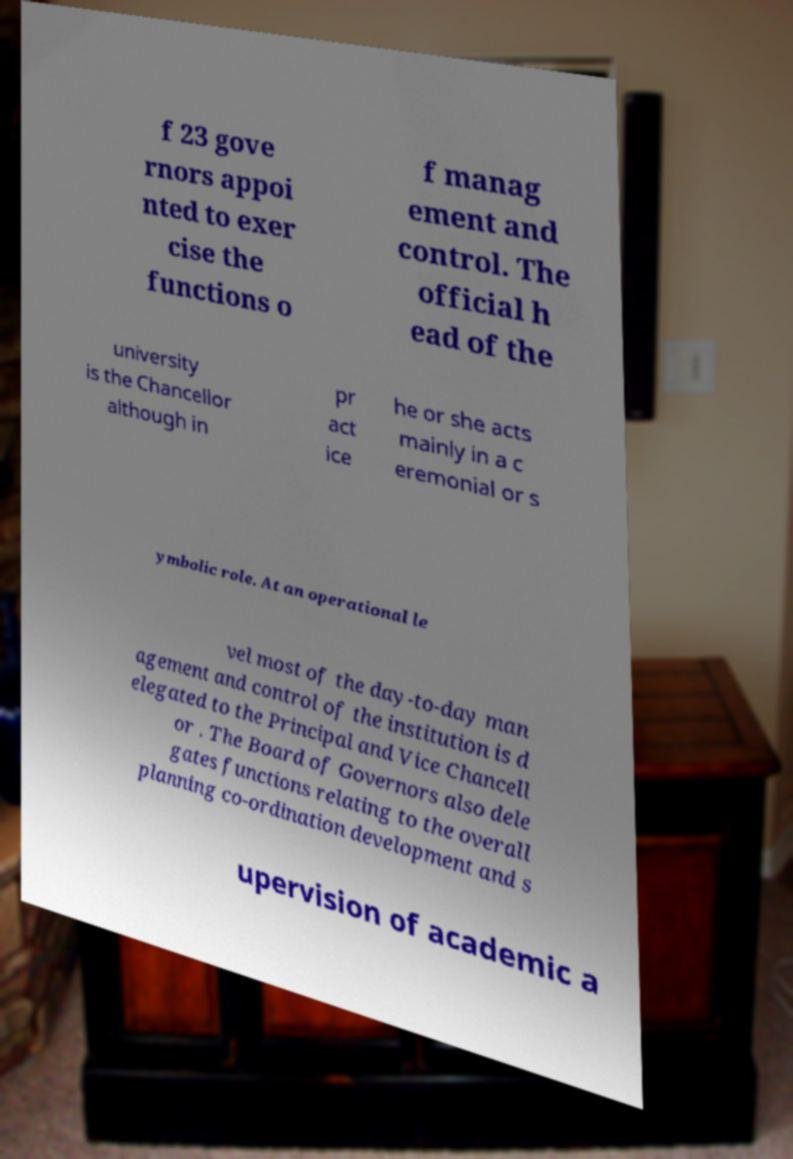Could you assist in decoding the text presented in this image and type it out clearly? f 23 gove rnors appoi nted to exer cise the functions o f manag ement and control. The official h ead of the university is the Chancellor although in pr act ice he or she acts mainly in a c eremonial or s ymbolic role. At an operational le vel most of the day-to-day man agement and control of the institution is d elegated to the Principal and Vice Chancell or . The Board of Governors also dele gates functions relating to the overall planning co-ordination development and s upervision of academic a 